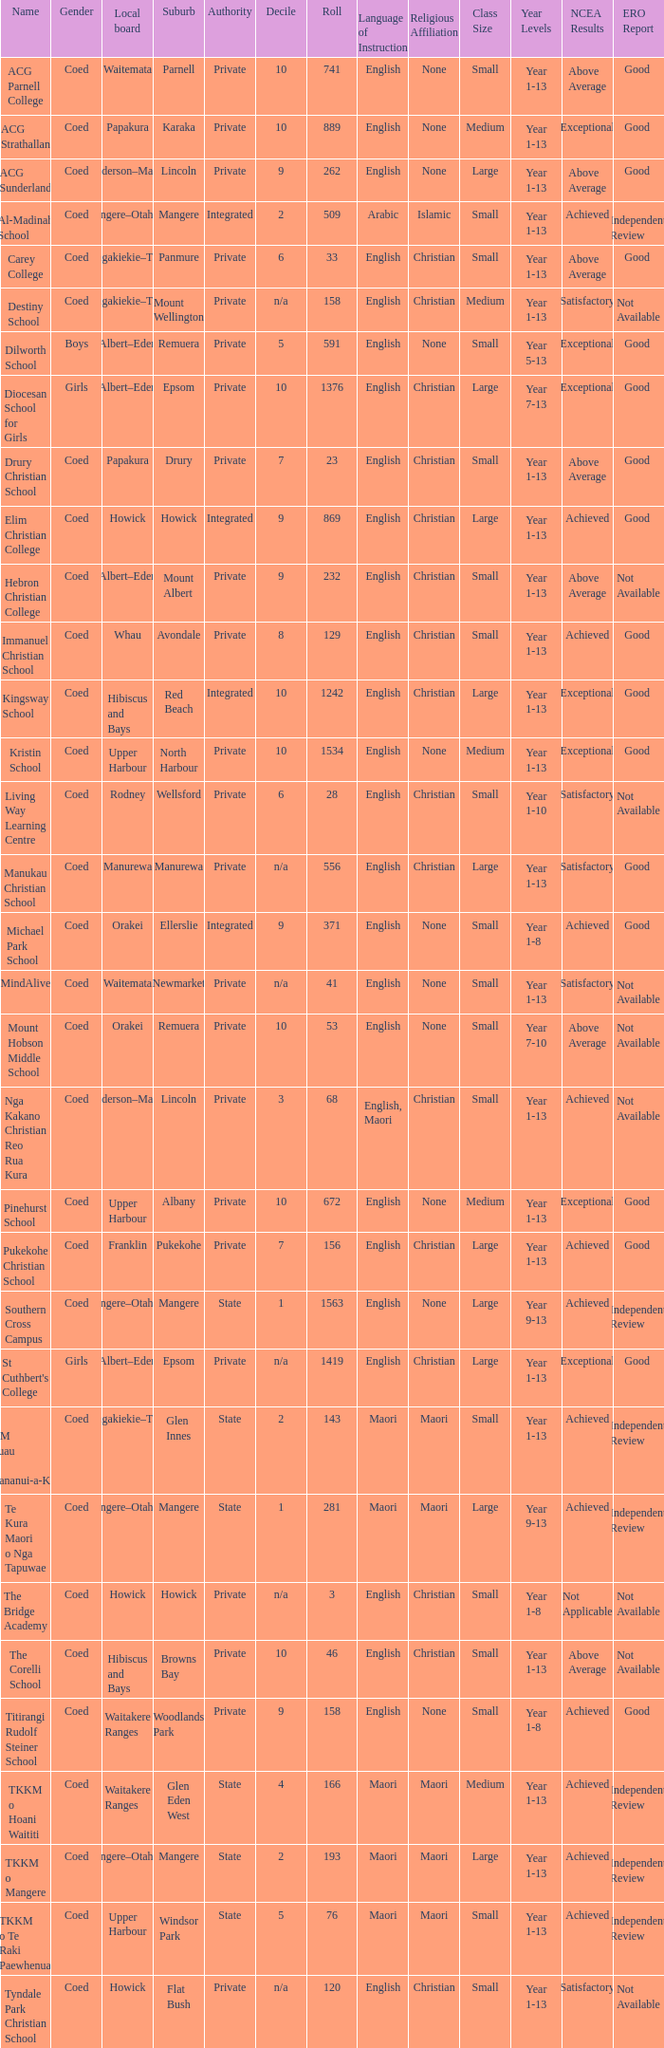What name shows as private authority and hibiscus and bays local board ? The Corelli School. 